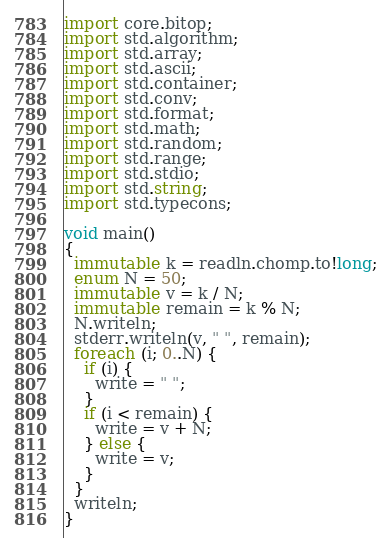Convert code to text. <code><loc_0><loc_0><loc_500><loc_500><_D_>import core.bitop;
import std.algorithm;
import std.array;
import std.ascii;
import std.container;
import std.conv;
import std.format;
import std.math;
import std.random;
import std.range;
import std.stdio;
import std.string;
import std.typecons;

void main()
{
  immutable k = readln.chomp.to!long;
  enum N = 50;
  immutable v = k / N;
  immutable remain = k % N;
  N.writeln;
  stderr.writeln(v, " ", remain);
  foreach (i; 0..N) {
    if (i) {
      write = " ";
    }
    if (i < remain) {
      write = v + N;
    } else {
      write = v;
    }
  }
  writeln;
}
</code> 